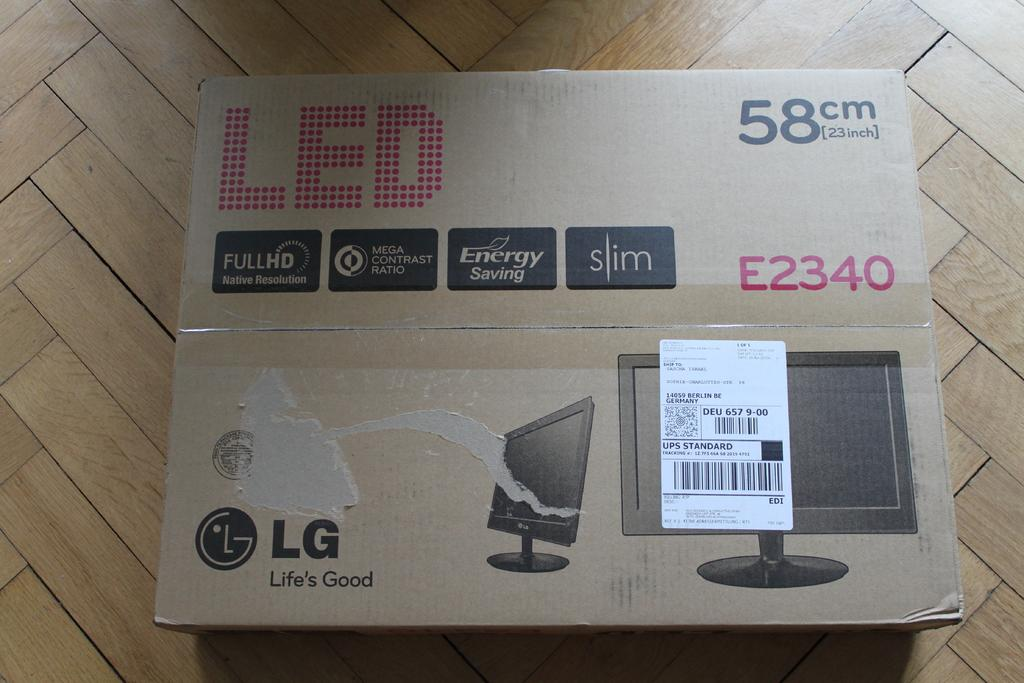<image>
Provide a brief description of the given image. A box with a monitor in it that is brand LG and is LED. 